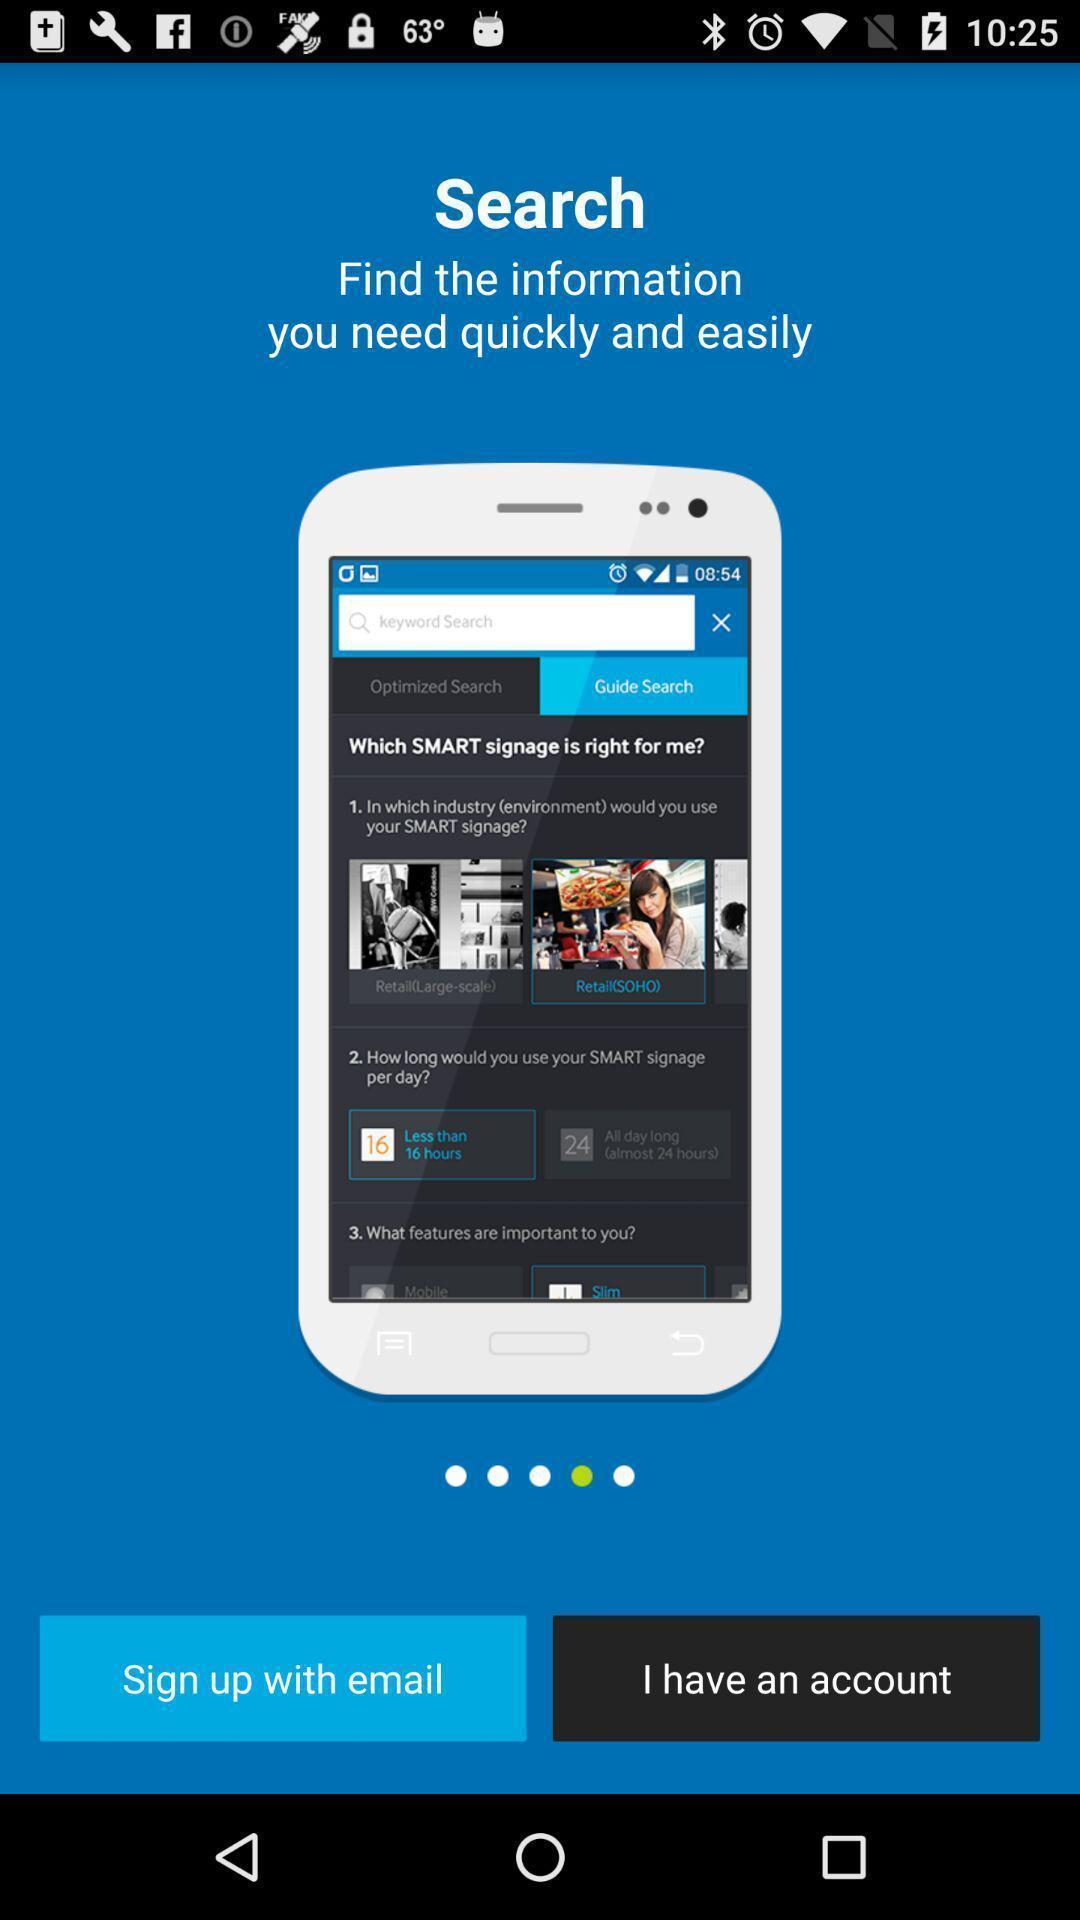What details can you identify in this image? Sign up page. 